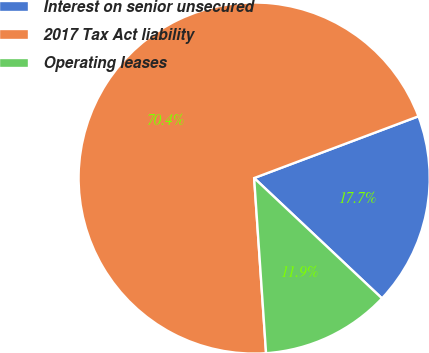Convert chart. <chart><loc_0><loc_0><loc_500><loc_500><pie_chart><fcel>Interest on senior unsecured<fcel>2017 Tax Act liability<fcel>Operating leases<nl><fcel>17.74%<fcel>70.36%<fcel>11.9%<nl></chart> 